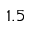Convert formula to latex. <formula><loc_0><loc_0><loc_500><loc_500>1 . 5</formula> 